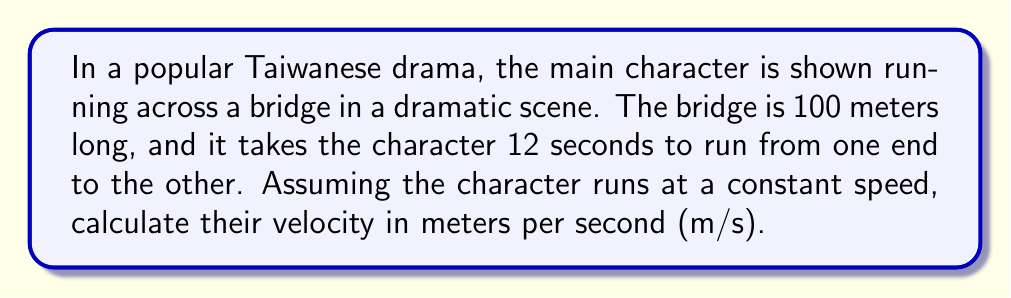Could you help me with this problem? Let's approach this step-by-step:

1) We know that velocity is defined as the rate of change of position with respect to time. The formula for average velocity is:

   $$ v = \frac{\Delta x}{\Delta t} $$

   Where $v$ is velocity, $\Delta x$ is the change in position (distance traveled), and $\Delta t$ is the change in time.

2) From the question, we have:
   - Distance ($\Delta x$) = 100 meters
   - Time ($\Delta t$) = 12 seconds

3) Let's substitute these values into our equation:

   $$ v = \frac{100 \text{ m}}{12 \text{ s}} $$

4) Now, we simply need to divide:

   $$ v = 8.33333... \text{ m/s} $$

5) Rounding to two decimal places for a reasonable precision:

   $$ v \approx 8.33 \text{ m/s} $$

Therefore, the character is running at a velocity of approximately 8.33 meters per second.
Answer: $8.33 \text{ m/s}$ 